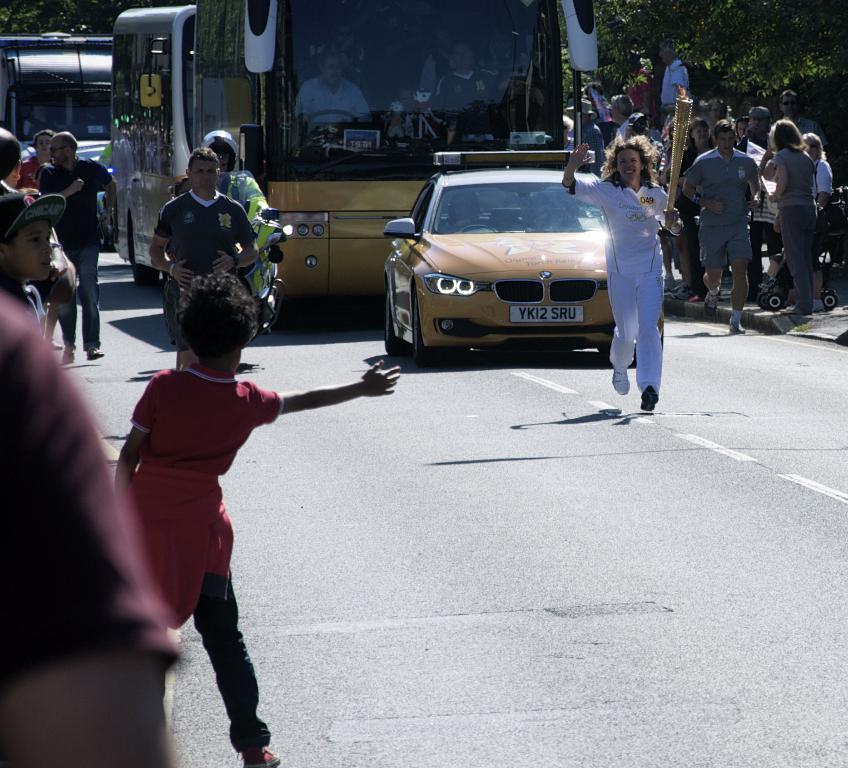Could you give a brief overview of what you see in this image? In this picture we can find some people are running, walking, and standing. In the background we can find a bus, car and a road with trees. 